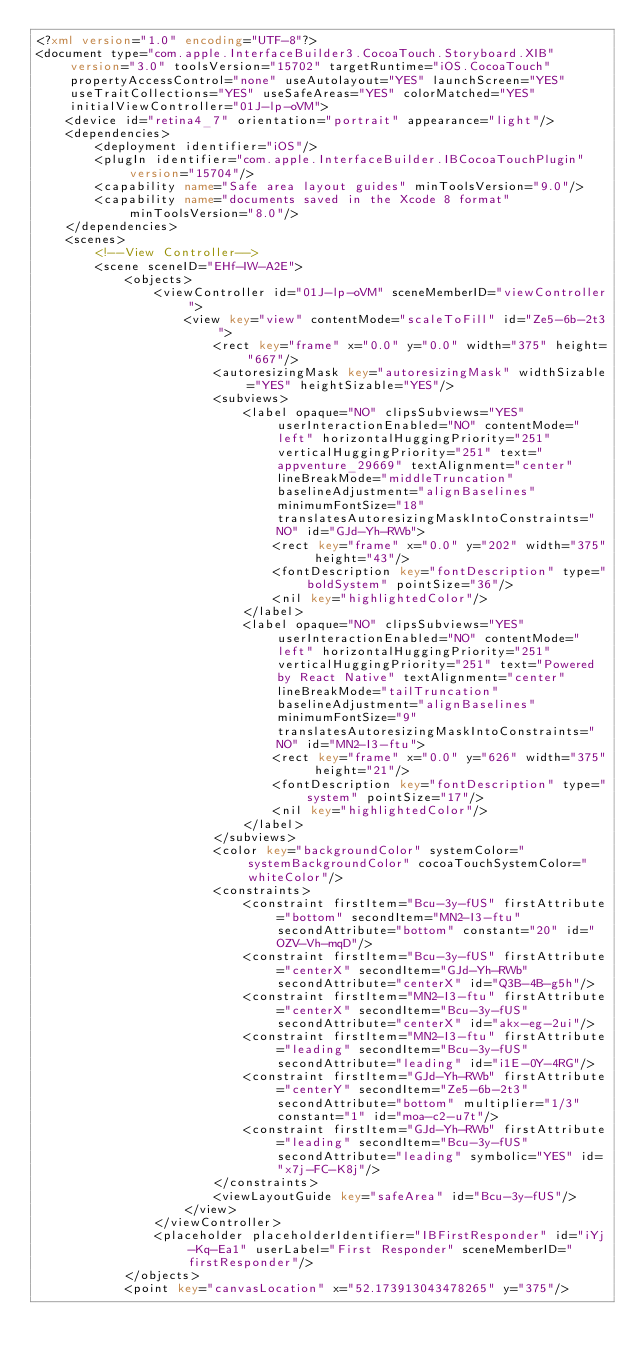Convert code to text. <code><loc_0><loc_0><loc_500><loc_500><_XML_><?xml version="1.0" encoding="UTF-8"?>
<document type="com.apple.InterfaceBuilder3.CocoaTouch.Storyboard.XIB" version="3.0" toolsVersion="15702" targetRuntime="iOS.CocoaTouch" propertyAccessControl="none" useAutolayout="YES" launchScreen="YES" useTraitCollections="YES" useSafeAreas="YES" colorMatched="YES" initialViewController="01J-lp-oVM">
    <device id="retina4_7" orientation="portrait" appearance="light"/>
    <dependencies>
        <deployment identifier="iOS"/>
        <plugIn identifier="com.apple.InterfaceBuilder.IBCocoaTouchPlugin" version="15704"/>
        <capability name="Safe area layout guides" minToolsVersion="9.0"/>
        <capability name="documents saved in the Xcode 8 format" minToolsVersion="8.0"/>
    </dependencies>
    <scenes>
        <!--View Controller-->
        <scene sceneID="EHf-IW-A2E">
            <objects>
                <viewController id="01J-lp-oVM" sceneMemberID="viewController">
                    <view key="view" contentMode="scaleToFill" id="Ze5-6b-2t3">
                        <rect key="frame" x="0.0" y="0.0" width="375" height="667"/>
                        <autoresizingMask key="autoresizingMask" widthSizable="YES" heightSizable="YES"/>
                        <subviews>
                            <label opaque="NO" clipsSubviews="YES" userInteractionEnabled="NO" contentMode="left" horizontalHuggingPriority="251" verticalHuggingPriority="251" text="appventure_29669" textAlignment="center" lineBreakMode="middleTruncation" baselineAdjustment="alignBaselines" minimumFontSize="18" translatesAutoresizingMaskIntoConstraints="NO" id="GJd-Yh-RWb">
                                <rect key="frame" x="0.0" y="202" width="375" height="43"/>
                                <fontDescription key="fontDescription" type="boldSystem" pointSize="36"/>
                                <nil key="highlightedColor"/>
                            </label>
                            <label opaque="NO" clipsSubviews="YES" userInteractionEnabled="NO" contentMode="left" horizontalHuggingPriority="251" verticalHuggingPriority="251" text="Powered by React Native" textAlignment="center" lineBreakMode="tailTruncation" baselineAdjustment="alignBaselines" minimumFontSize="9" translatesAutoresizingMaskIntoConstraints="NO" id="MN2-I3-ftu">
                                <rect key="frame" x="0.0" y="626" width="375" height="21"/>
                                <fontDescription key="fontDescription" type="system" pointSize="17"/>
                                <nil key="highlightedColor"/>
                            </label>
                        </subviews>
                        <color key="backgroundColor" systemColor="systemBackgroundColor" cocoaTouchSystemColor="whiteColor"/>
                        <constraints>
                            <constraint firstItem="Bcu-3y-fUS" firstAttribute="bottom" secondItem="MN2-I3-ftu" secondAttribute="bottom" constant="20" id="OZV-Vh-mqD"/>
                            <constraint firstItem="Bcu-3y-fUS" firstAttribute="centerX" secondItem="GJd-Yh-RWb" secondAttribute="centerX" id="Q3B-4B-g5h"/>
                            <constraint firstItem="MN2-I3-ftu" firstAttribute="centerX" secondItem="Bcu-3y-fUS" secondAttribute="centerX" id="akx-eg-2ui"/>
                            <constraint firstItem="MN2-I3-ftu" firstAttribute="leading" secondItem="Bcu-3y-fUS" secondAttribute="leading" id="i1E-0Y-4RG"/>
                            <constraint firstItem="GJd-Yh-RWb" firstAttribute="centerY" secondItem="Ze5-6b-2t3" secondAttribute="bottom" multiplier="1/3" constant="1" id="moa-c2-u7t"/>
                            <constraint firstItem="GJd-Yh-RWb" firstAttribute="leading" secondItem="Bcu-3y-fUS" secondAttribute="leading" symbolic="YES" id="x7j-FC-K8j"/>
                        </constraints>
                        <viewLayoutGuide key="safeArea" id="Bcu-3y-fUS"/>
                    </view>
                </viewController>
                <placeholder placeholderIdentifier="IBFirstResponder" id="iYj-Kq-Ea1" userLabel="First Responder" sceneMemberID="firstResponder"/>
            </objects>
            <point key="canvasLocation" x="52.173913043478265" y="375"/></code> 